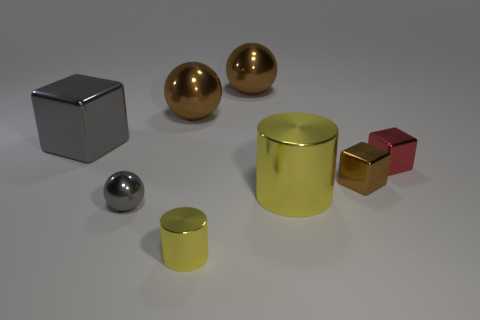What number of tiny things are either cylinders or brown objects?
Provide a succinct answer. 2. What is the big yellow cylinder made of?
Your answer should be compact. Metal. What is the cube that is to the left of the red metallic block and in front of the big block made of?
Offer a very short reply. Metal. There is a small cylinder; is its color the same as the big object that is in front of the small red thing?
Provide a succinct answer. Yes. What is the material of the cylinder that is the same size as the gray block?
Your response must be concise. Metal. Are there any other tiny yellow cylinders made of the same material as the tiny yellow cylinder?
Keep it short and to the point. No. How many large blue matte things are there?
Offer a very short reply. 0. Is the material of the red block the same as the thing that is left of the small gray metal ball?
Your answer should be compact. Yes. There is a tiny object that is the same color as the big shiny cube; what is it made of?
Ensure brevity in your answer.  Metal. What number of objects have the same color as the big shiny cylinder?
Ensure brevity in your answer.  1. 